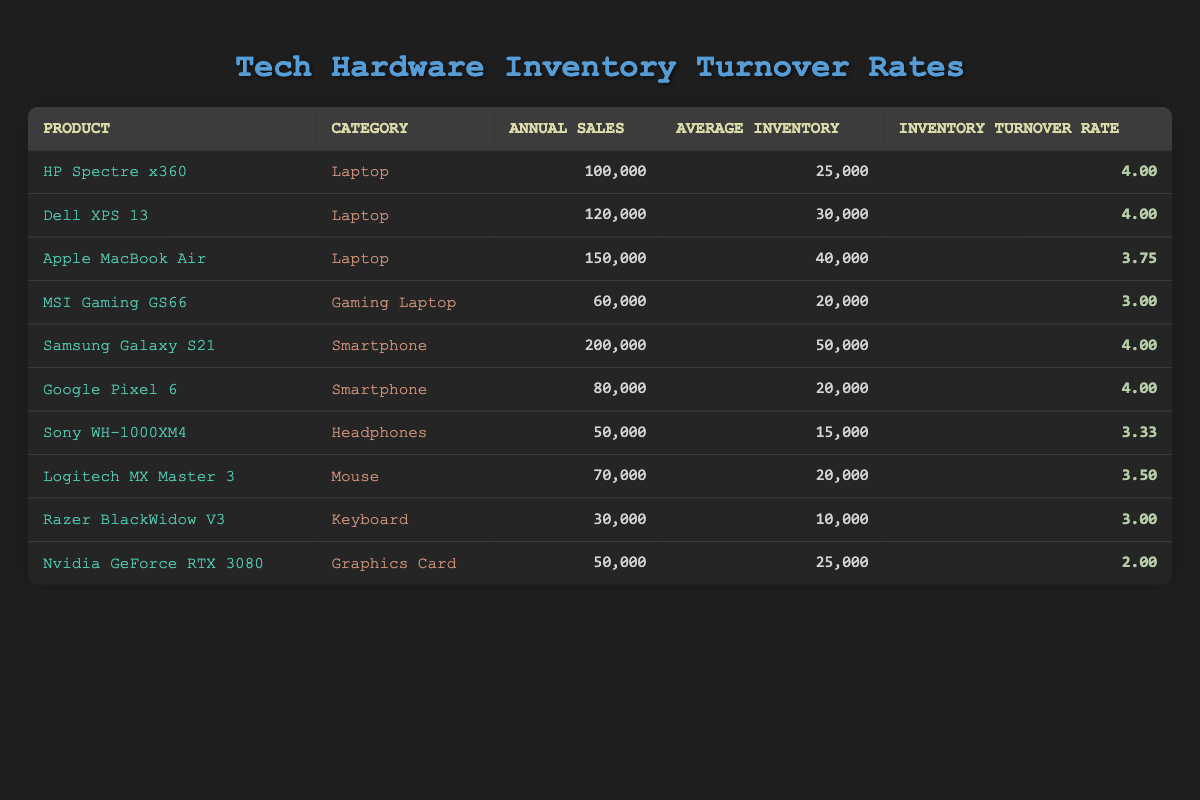What's the inventory turnover rate for the Dell XPS 13? The table lists the Dell XPS 13 under the Laptop category with an inventory turnover rate of 4.0.
Answer: 4.0 What is the average annual sales for the laptops listed? The annual sales for the laptops are 100,000 (HP Spectre x360), 120,000 (Dell XPS 13), and 150,000 (Apple MacBook Air), totaling 370,000 sales. Dividing by the number of laptops (3), the average is 370,000 / 3 = 123,333.33.
Answer: 123,333.33 Is the inventory turnover rate for the Samsung Galaxy S21 greater than 3.5? The Samsung Galaxy S21 has an inventory turnover rate of 4.0, which is greater than 3.5.
Answer: Yes Which product has the highest inventory turnover rate? The table indicates that the HP Spectre x360, Dell XPS 13, and Samsung Galaxy S21 all share the highest inventory turnover rate of 4.0; therefore, there are multiple products tied for this rate.
Answer: HP Spectre x360, Dell XPS 13, Samsung Galaxy S21 What is the total annual sales for all products in the Smartphone category? The annual sales for smartphones are 200,000 (Samsung Galaxy S21) and 80,000 (Google Pixel 6), giving a total of 200,000 + 80,000 = 280,000 for the Smartphone category.
Answer: 280,000 How many products have an inventory turnover rate below 3.5? The products with an inventory turnover rate below 3.5 are the MSI Gaming GS66 (3.0), Razer BlackWidow V3 (3.0), and Nvidia GeForce RTX 3080 (2.0), totaling 3 products with lower rates.
Answer: 3 What is the difference in average inventory between the product with the lowest turnover rate and the highest turnover rate? The product with the lowest turnover rate is the Nvidia GeForce RTX 3080 with an average inventory of 25,000. The product with the highest turnover rate (shared by three) is the Dell XPS 13 (or HP Spectre x360, or Samsung Galaxy S21) with an average inventory of 30,000 (or 25,000). The differences are calculated as 30,000 - 25,000 = 5,000 for the highest.
Answer: 5,000 Is the average inventory for all laptops greater than 30,000? The average inventory for laptops is (25,000 + 30,000 + 40,000) / 3 = 31,666.67, which is indeed greater than 30,000.
Answer: Yes Which category has the lowest total annual sales? By adding annual sales for each category, we find Laptops totaling 370,000, Smartphones 280,000, Gaming Laptops 60,000, Headphones 50,000, Mice 70,000, Keyboards 30,000, and Graphics Cards 50,000. The lowest total is for the Keyboard category with 30,000.
Answer: Keyboard 